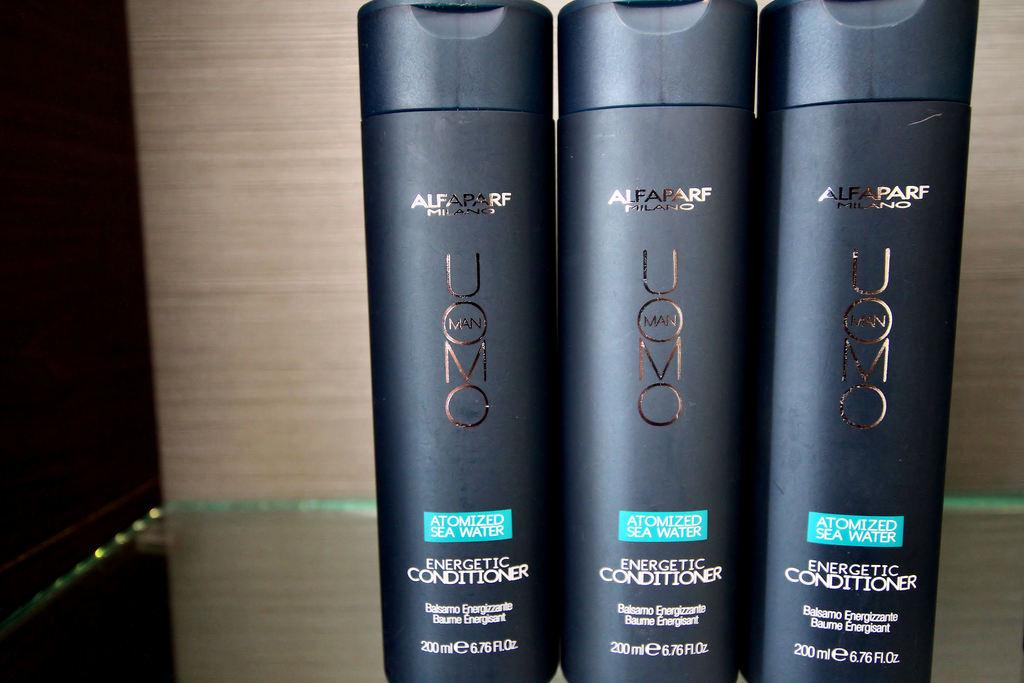<image>
Offer a succinct explanation of the picture presented. Three black bottles of energetic conditioner for men 